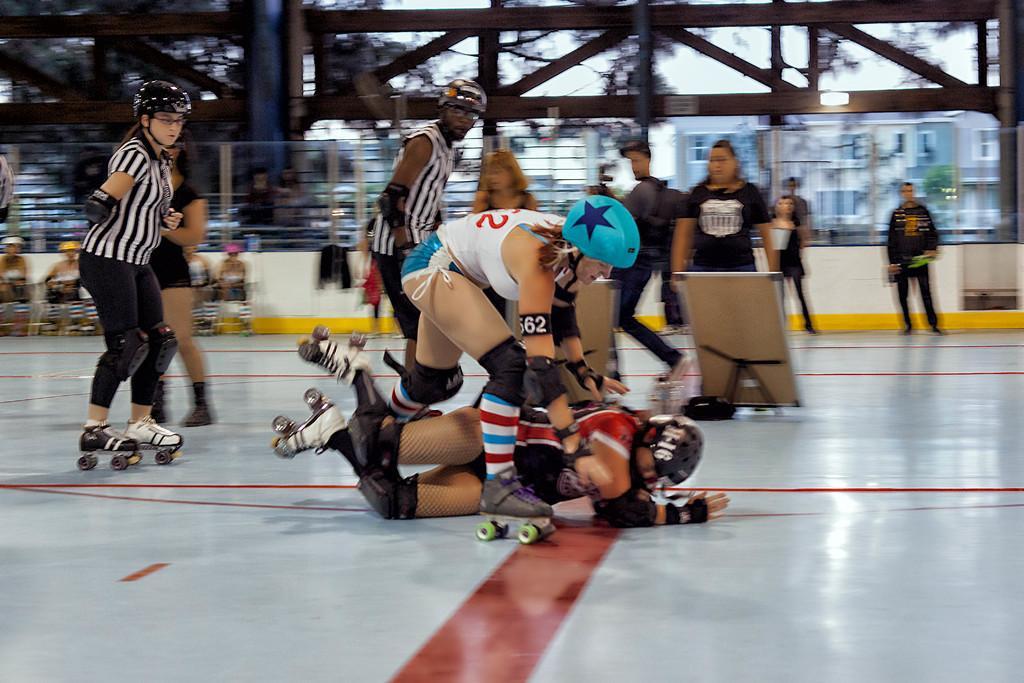Can you describe this image briefly? In this image, I can see few people doing skating. This is the board, which is placed on the skating area. I can see a person falling. I think I can see few people sitting. The background looks blurry. 